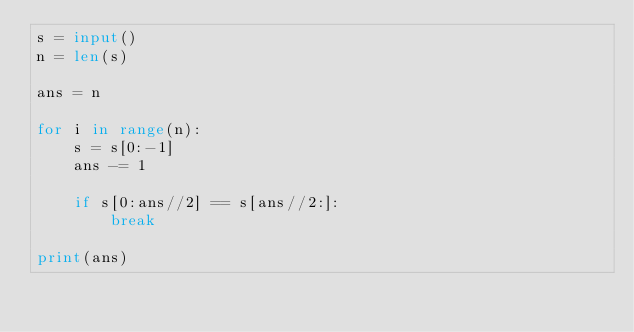Convert code to text. <code><loc_0><loc_0><loc_500><loc_500><_Python_>s = input()
n = len(s)

ans = n

for i in range(n):
    s = s[0:-1]
    ans -= 1

    if s[0:ans//2] == s[ans//2:]:
        break

print(ans)</code> 